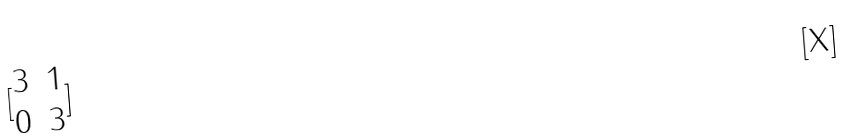Convert formula to latex. <formula><loc_0><loc_0><loc_500><loc_500>[ \begin{matrix} 3 & 1 \\ 0 & 3 \end{matrix} ]</formula> 